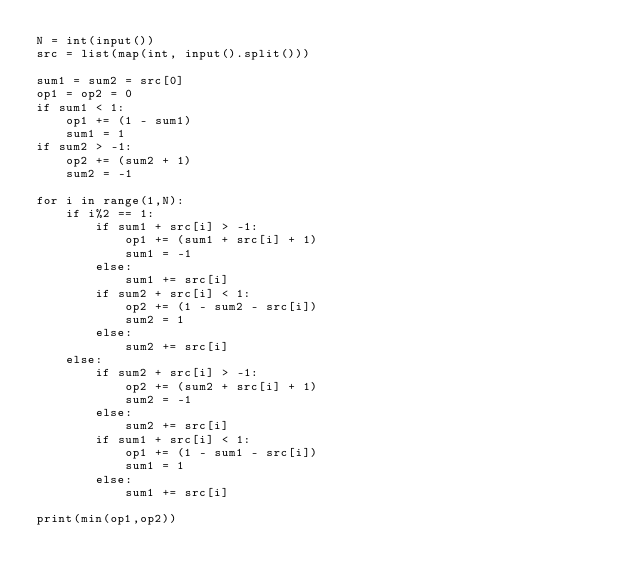Convert code to text. <code><loc_0><loc_0><loc_500><loc_500><_Python_>N = int(input())
src = list(map(int, input().split()))

sum1 = sum2 = src[0]
op1 = op2 = 0
if sum1 < 1:
    op1 += (1 - sum1)
    sum1 = 1
if sum2 > -1:
    op2 += (sum2 + 1)
    sum2 = -1

for i in range(1,N):
    if i%2 == 1:
        if sum1 + src[i] > -1:
            op1 += (sum1 + src[i] + 1)
            sum1 = -1
        else:
            sum1 += src[i]
        if sum2 + src[i] < 1:
            op2 += (1 - sum2 - src[i])
            sum2 = 1
        else:
            sum2 += src[i]
    else:
        if sum2 + src[i] > -1:
            op2 += (sum2 + src[i] + 1)
            sum2 = -1
        else:
            sum2 += src[i]
        if sum1 + src[i] < 1:
            op1 += (1 - sum1 - src[i])
            sum1 = 1
        else:
            sum1 += src[i]

print(min(op1,op2))
</code> 